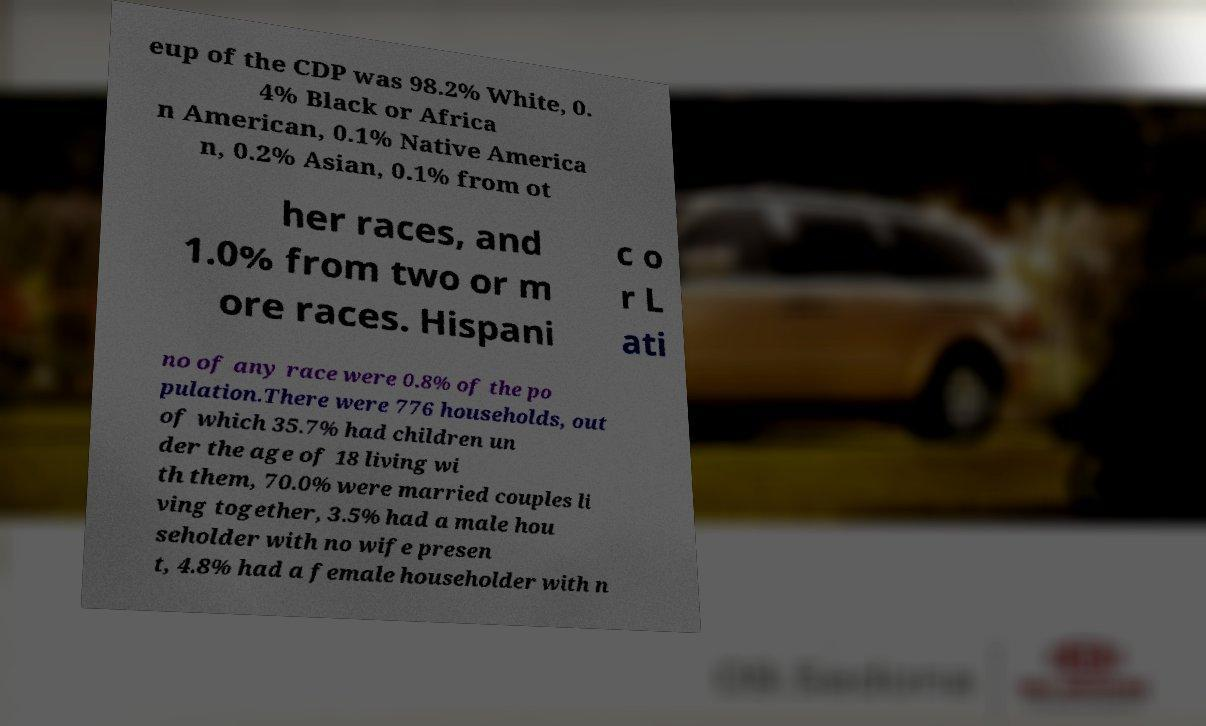For documentation purposes, I need the text within this image transcribed. Could you provide that? eup of the CDP was 98.2% White, 0. 4% Black or Africa n American, 0.1% Native America n, 0.2% Asian, 0.1% from ot her races, and 1.0% from two or m ore races. Hispani c o r L ati no of any race were 0.8% of the po pulation.There were 776 households, out of which 35.7% had children un der the age of 18 living wi th them, 70.0% were married couples li ving together, 3.5% had a male hou seholder with no wife presen t, 4.8% had a female householder with n 